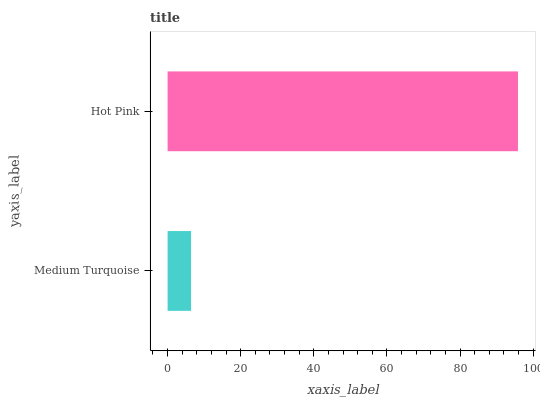Is Medium Turquoise the minimum?
Answer yes or no. Yes. Is Hot Pink the maximum?
Answer yes or no. Yes. Is Hot Pink the minimum?
Answer yes or no. No. Is Hot Pink greater than Medium Turquoise?
Answer yes or no. Yes. Is Medium Turquoise less than Hot Pink?
Answer yes or no. Yes. Is Medium Turquoise greater than Hot Pink?
Answer yes or no. No. Is Hot Pink less than Medium Turquoise?
Answer yes or no. No. Is Hot Pink the high median?
Answer yes or no. Yes. Is Medium Turquoise the low median?
Answer yes or no. Yes. Is Medium Turquoise the high median?
Answer yes or no. No. Is Hot Pink the low median?
Answer yes or no. No. 